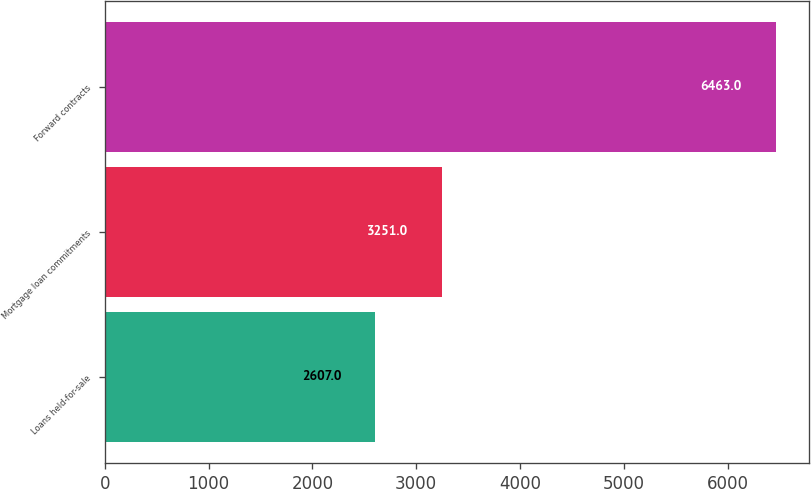Convert chart. <chart><loc_0><loc_0><loc_500><loc_500><bar_chart><fcel>Loans held-for-sale<fcel>Mortgage loan commitments<fcel>Forward contracts<nl><fcel>2607<fcel>3251<fcel>6463<nl></chart> 